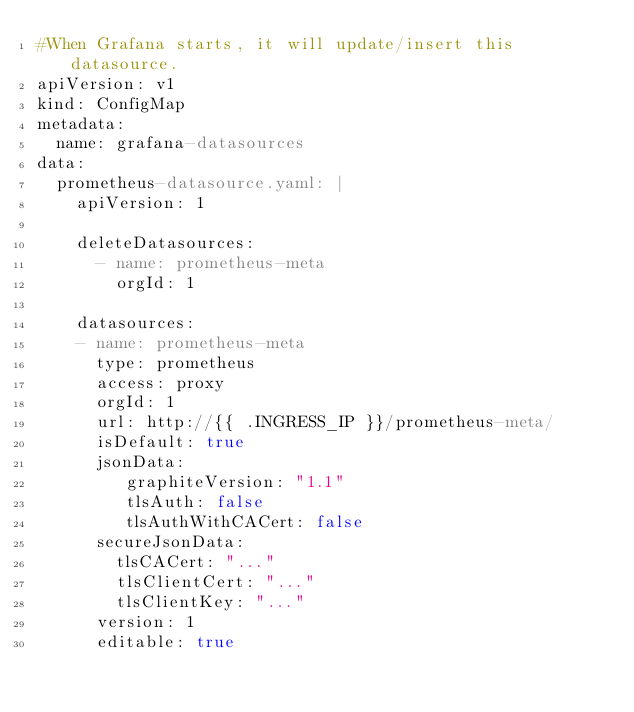Convert code to text. <code><loc_0><loc_0><loc_500><loc_500><_YAML_>#When Grafana starts, it will update/insert this datasource.
apiVersion: v1
kind: ConfigMap
metadata:
  name: grafana-datasources
data:
  prometheus-datasource.yaml: |
    apiVersion: 1

    deleteDatasources:
      - name: prometheus-meta
        orgId: 1

    datasources:
    - name: prometheus-meta
      type: prometheus
      access: proxy
      orgId: 1
      url: http://{{ .INGRESS_IP }}/prometheus-meta/
      isDefault: true
      jsonData:
         graphiteVersion: "1.1"
         tlsAuth: false
         tlsAuthWithCACert: false
      secureJsonData:
        tlsCACert: "..."
        tlsClientCert: "..."
        tlsClientKey: "..."
      version: 1
      editable: true
</code> 